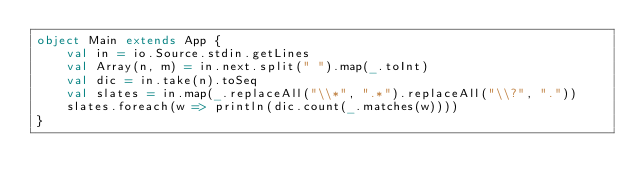<code> <loc_0><loc_0><loc_500><loc_500><_Scala_>object Main extends App {
    val in = io.Source.stdin.getLines
    val Array(n, m) = in.next.split(" ").map(_.toInt)
    val dic = in.take(n).toSeq
    val slates = in.map(_.replaceAll("\\*", ".*").replaceAll("\\?", "."))
    slates.foreach(w => println(dic.count(_.matches(w))))
}</code> 